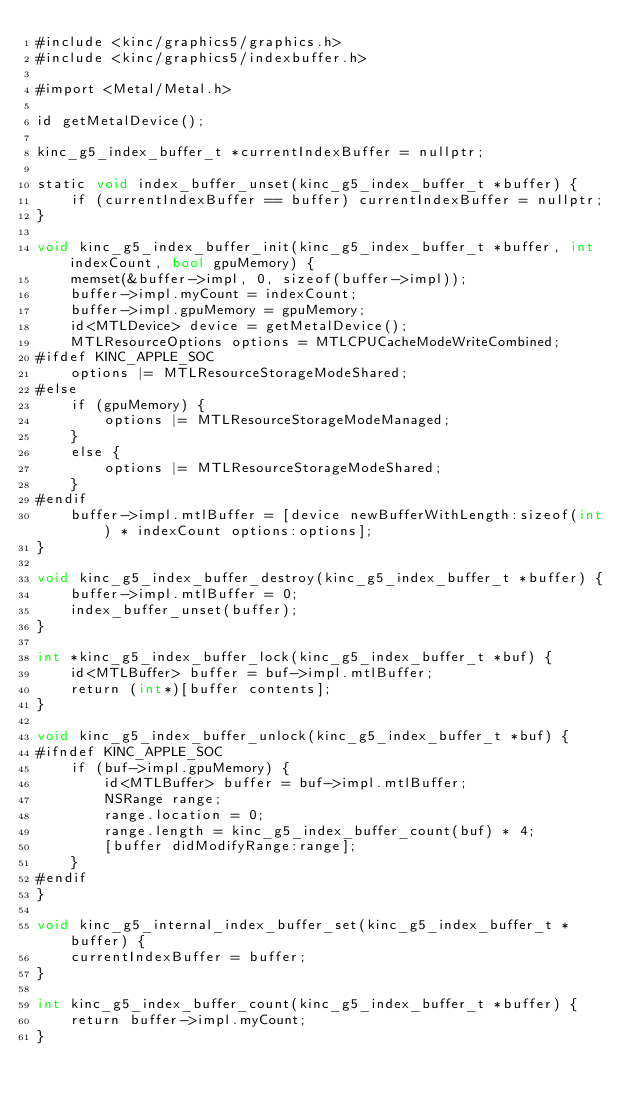<code> <loc_0><loc_0><loc_500><loc_500><_ObjectiveC_>#include <kinc/graphics5/graphics.h>
#include <kinc/graphics5/indexbuffer.h>

#import <Metal/Metal.h>

id getMetalDevice();

kinc_g5_index_buffer_t *currentIndexBuffer = nullptr;

static void index_buffer_unset(kinc_g5_index_buffer_t *buffer) {
	if (currentIndexBuffer == buffer) currentIndexBuffer = nullptr;
}

void kinc_g5_index_buffer_init(kinc_g5_index_buffer_t *buffer, int indexCount, bool gpuMemory) {
	memset(&buffer->impl, 0, sizeof(buffer->impl));
	buffer->impl.myCount = indexCount;
	buffer->impl.gpuMemory = gpuMemory;
	id<MTLDevice> device = getMetalDevice();
	MTLResourceOptions options = MTLCPUCacheModeWriteCombined;
#ifdef KINC_APPLE_SOC
	options |= MTLResourceStorageModeShared;
#else
	if (gpuMemory) {
		options |= MTLResourceStorageModeManaged;
	}
	else {
		options |= MTLResourceStorageModeShared;
	}
#endif
	buffer->impl.mtlBuffer = [device newBufferWithLength:sizeof(int) * indexCount options:options];
}

void kinc_g5_index_buffer_destroy(kinc_g5_index_buffer_t *buffer) {
	buffer->impl.mtlBuffer = 0;
	index_buffer_unset(buffer);
}

int *kinc_g5_index_buffer_lock(kinc_g5_index_buffer_t *buf) {
	id<MTLBuffer> buffer = buf->impl.mtlBuffer;
	return (int*)[buffer contents];
}

void kinc_g5_index_buffer_unlock(kinc_g5_index_buffer_t *buf) {
#ifndef KINC_APPLE_SOC
	if (buf->impl.gpuMemory) {
		id<MTLBuffer> buffer = buf->impl.mtlBuffer;
		NSRange range;
		range.location = 0;
		range.length = kinc_g5_index_buffer_count(buf) * 4;
		[buffer didModifyRange:range];
	}
#endif
}

void kinc_g5_internal_index_buffer_set(kinc_g5_index_buffer_t *buffer) {
	currentIndexBuffer = buffer;
}

int kinc_g5_index_buffer_count(kinc_g5_index_buffer_t *buffer) {
	return buffer->impl.myCount;
}
</code> 